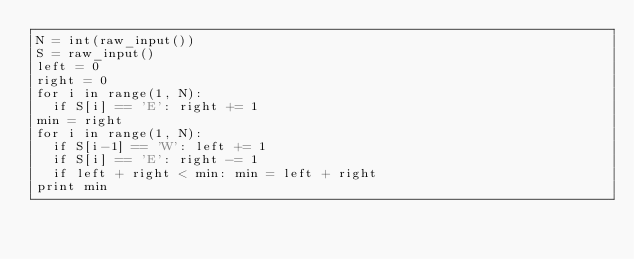<code> <loc_0><loc_0><loc_500><loc_500><_Python_>N = int(raw_input())
S = raw_input()
left = 0
right = 0
for i in range(1, N):
	if S[i] == 'E': right += 1
min = right
for i in range(1, N):
	if S[i-1] == 'W': left += 1
	if S[i] == 'E': right -= 1
	if left + right < min: min = left + right
print min</code> 